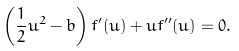Convert formula to latex. <formula><loc_0><loc_0><loc_500><loc_500>\left ( \frac { 1 } { 2 } u ^ { 2 } - b \right ) f ^ { \prime } ( u ) + u f ^ { \prime \prime } ( u ) = 0 .</formula> 